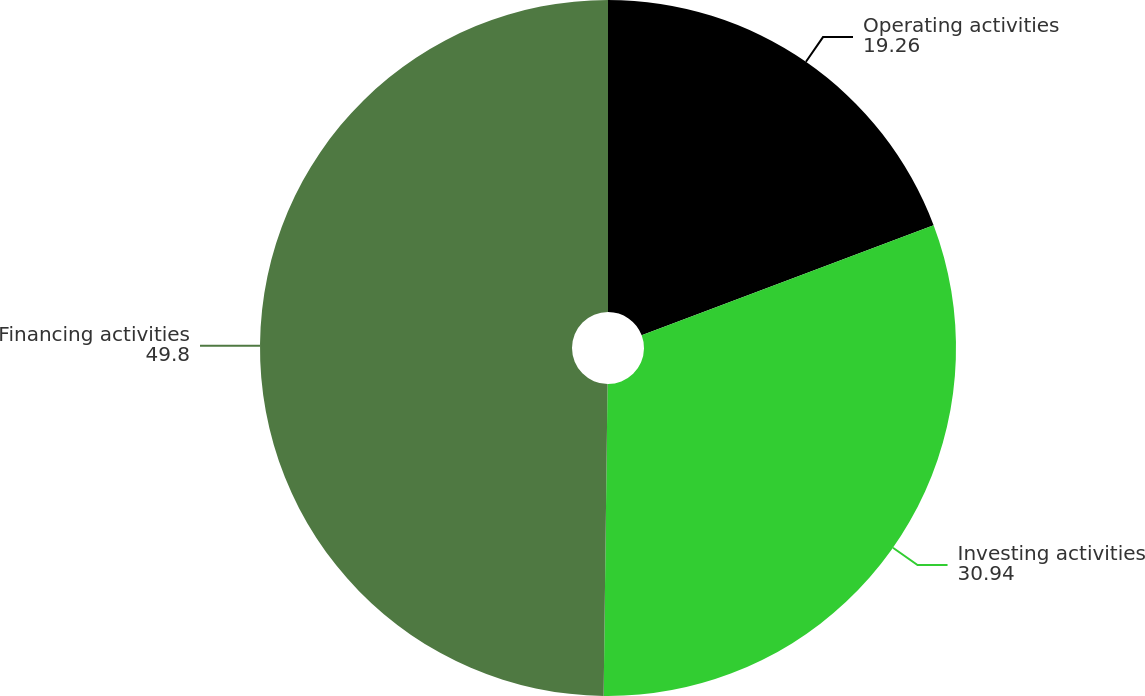Convert chart to OTSL. <chart><loc_0><loc_0><loc_500><loc_500><pie_chart><fcel>Operating activities<fcel>Investing activities<fcel>Financing activities<nl><fcel>19.26%<fcel>30.94%<fcel>49.8%<nl></chart> 